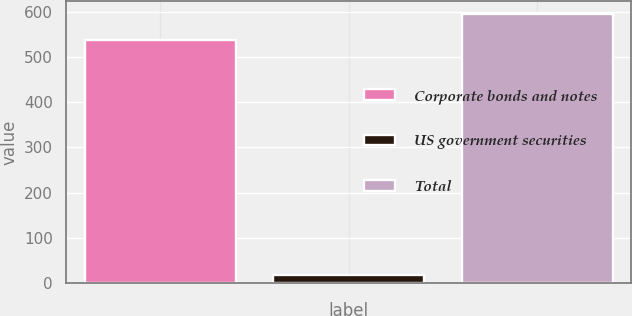Convert chart. <chart><loc_0><loc_0><loc_500><loc_500><bar_chart><fcel>Corporate bonds and notes<fcel>US government securities<fcel>Total<nl><fcel>538<fcel>17<fcel>595.1<nl></chart> 